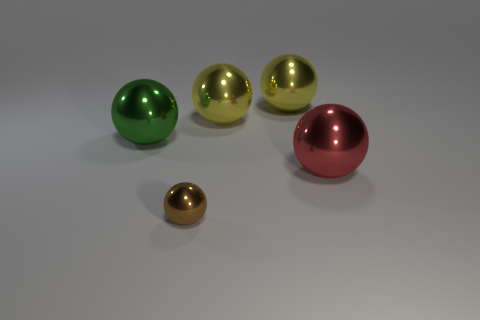Subtract all red metal spheres. How many spheres are left? 4 Subtract all yellow blocks. How many yellow balls are left? 2 Subtract all red balls. How many balls are left? 4 Subtract 3 spheres. How many spheres are left? 2 Add 3 tiny red spheres. How many objects exist? 8 Subtract 0 blue cubes. How many objects are left? 5 Subtract all blue spheres. Subtract all yellow cylinders. How many spheres are left? 5 Subtract all yellow cylinders. Subtract all green metal spheres. How many objects are left? 4 Add 5 tiny brown objects. How many tiny brown objects are left? 6 Add 3 tiny shiny things. How many tiny shiny things exist? 4 